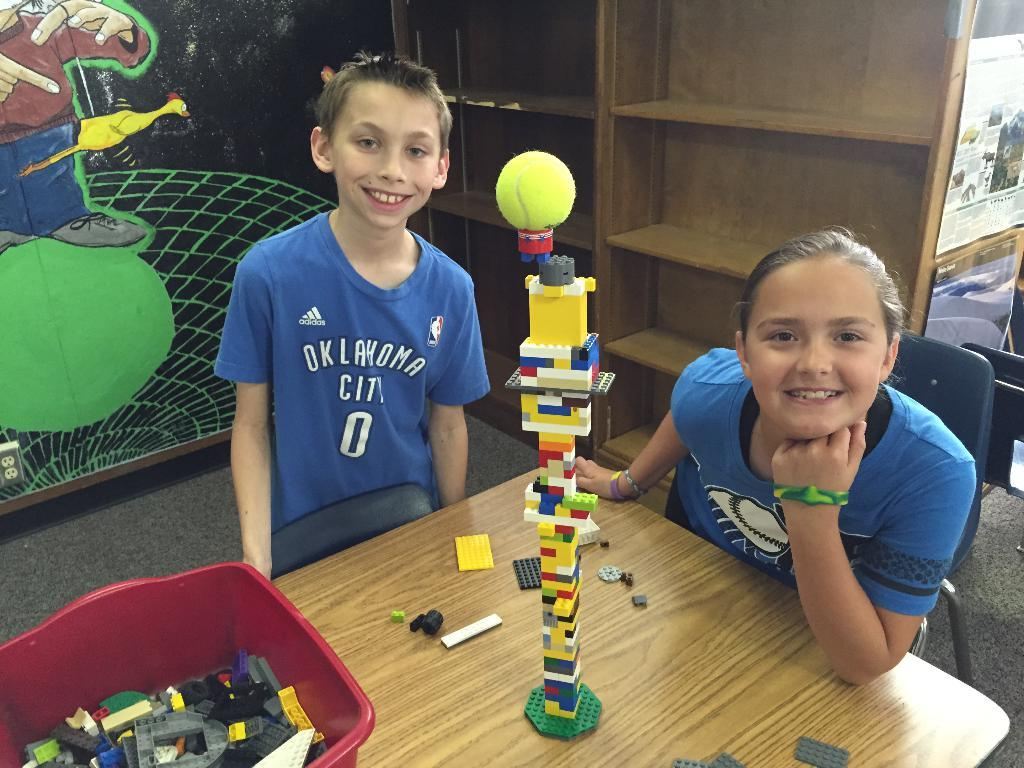How many people are present in the image? There is a girl and a boy in the image. What are the expressions on their faces? Both the girl and the boy are smiling. What type of furniture is in the image? There are chairs in the image. What can be found in the basket in the image? There are toys in a basket in the image. What is on the table in the image? There are toys on a table in the image. What else can be seen in the image besides the people and toys? There are papers and wooden shelves in the image. What sign is the girl holding in the image? There is no sign present in the image; the girl is not holding anything. 